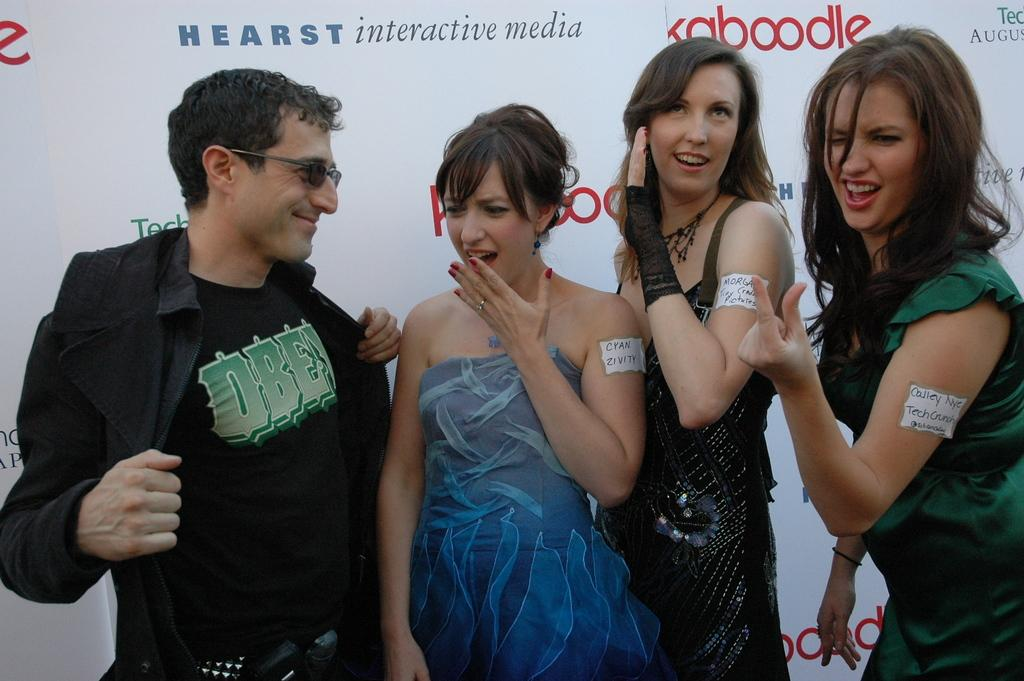How many people are in the image? There are four people in the image, including one man and three women. What are the people in the image doing? The people are standing and smiling in the image. What can be seen in the background of the image? There is a banner in the background of the image. How many girls are crying in the image? There are no girls or crying depicted in the image. Can you see a bee buzzing around the people in the image? There is no bee present in the image. 